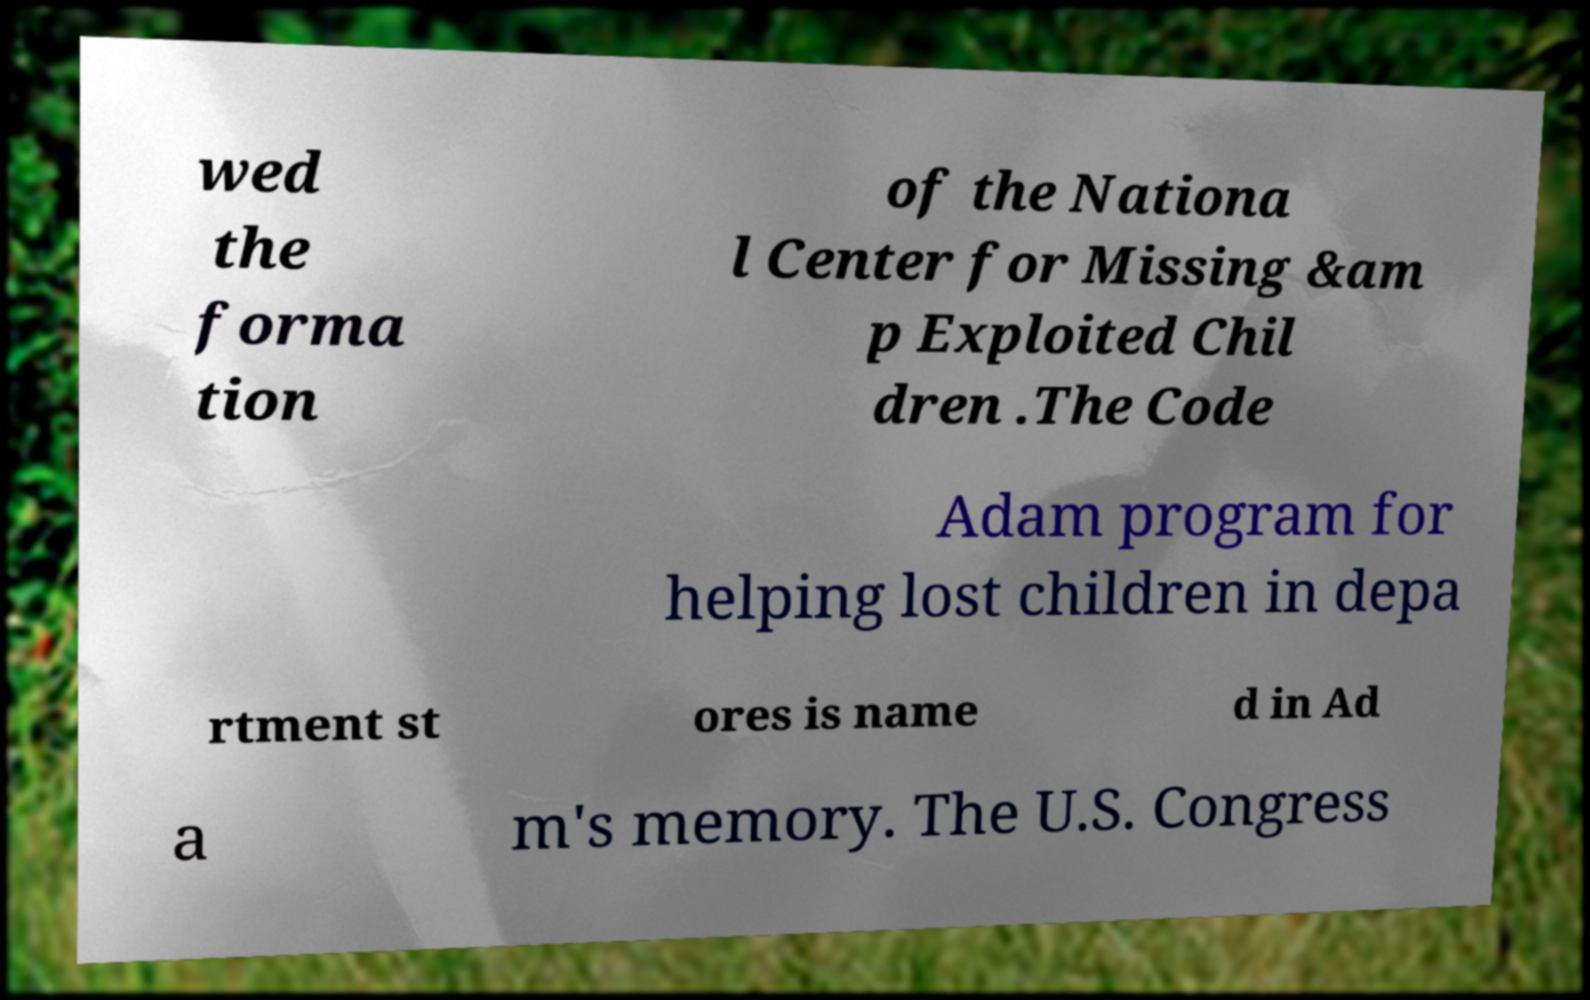Please read and relay the text visible in this image. What does it say? wed the forma tion of the Nationa l Center for Missing &am p Exploited Chil dren .The Code Adam program for helping lost children in depa rtment st ores is name d in Ad a m's memory. The U.S. Congress 